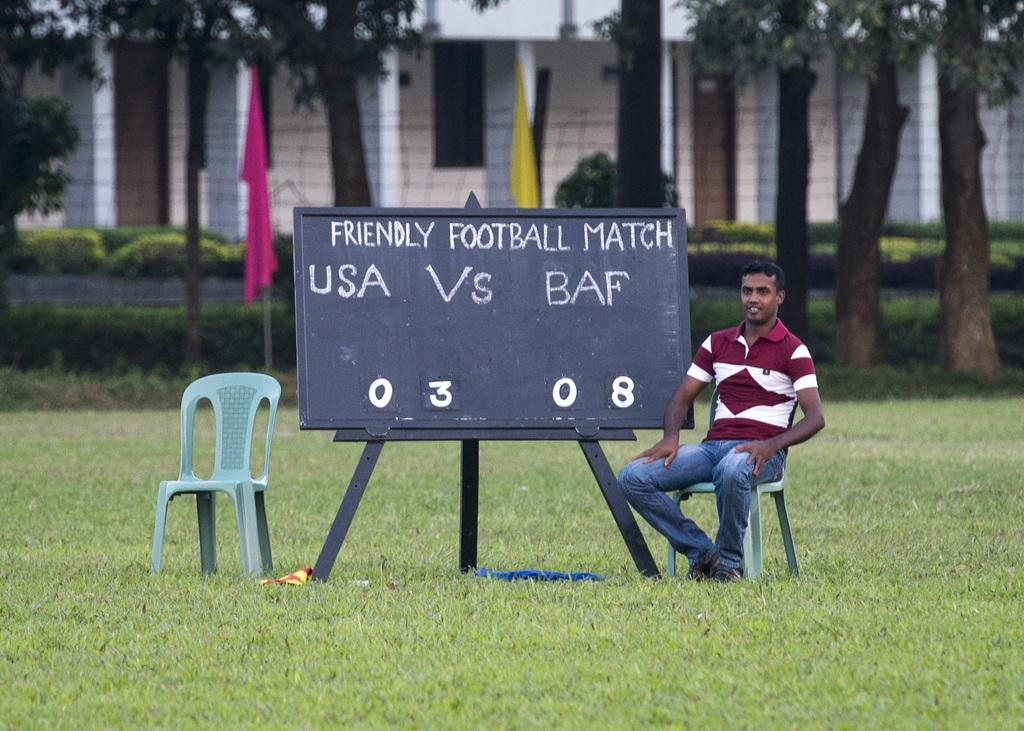What is the man in the image doing? The man is sitting on a chair in the image. What object is present in the image that is typically used for writing or displaying information? There is a blackboard in the image. What type of structure can be seen in the background of the image? There is a building in the image. What are the flags in the image used for? The flags in the image are used for identification or representation. What type of vegetation is present in the image? There are trees in the image. What type of ground cover is visible in the image? There is grass on the ground in the image. What type of shade is provided by the ducks in the image? There are no ducks present in the image, so no shade is provided by them. 